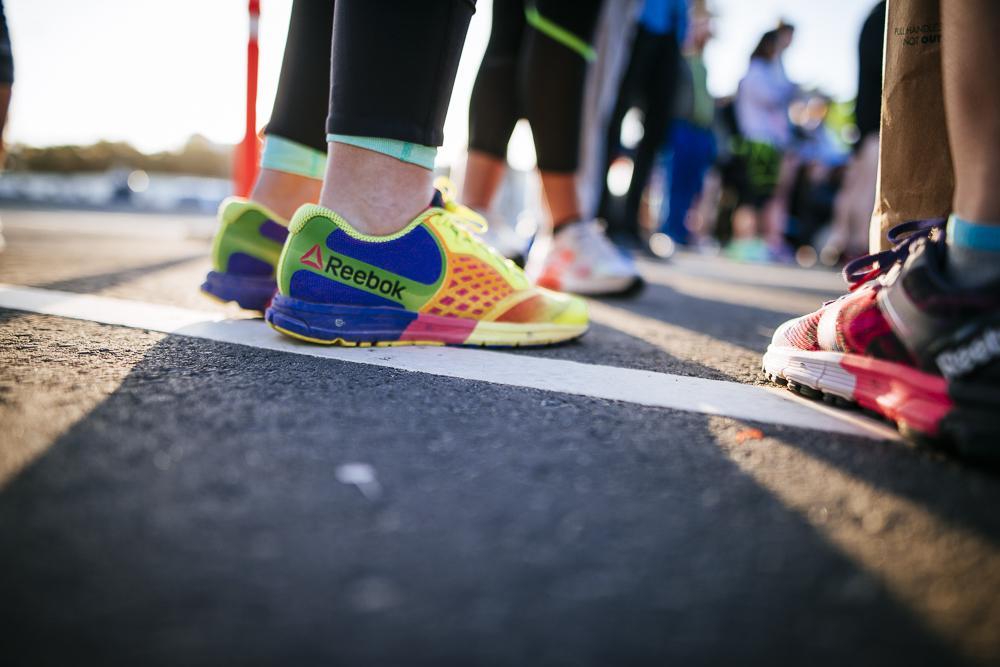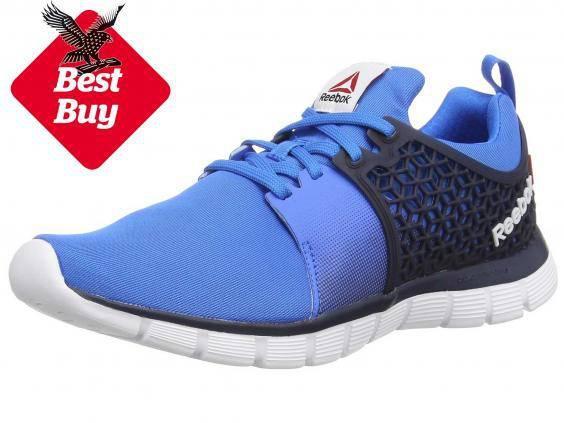The first image is the image on the left, the second image is the image on the right. Examine the images to the left and right. Is the description "The left image shows running shoes that are being worn on human feet" accurate? Answer yes or no. Yes. 